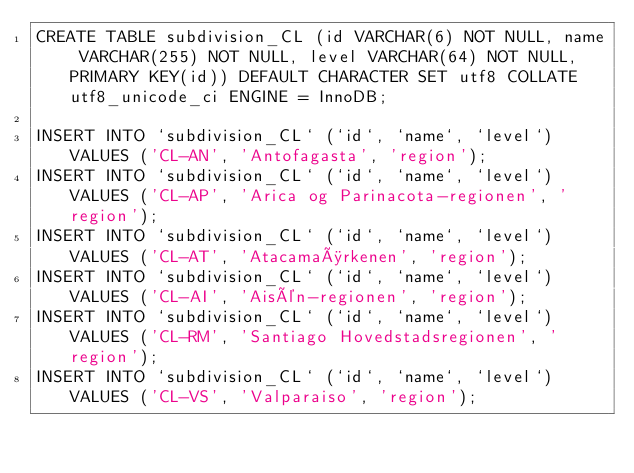<code> <loc_0><loc_0><loc_500><loc_500><_SQL_>CREATE TABLE subdivision_CL (id VARCHAR(6) NOT NULL, name VARCHAR(255) NOT NULL, level VARCHAR(64) NOT NULL, PRIMARY KEY(id)) DEFAULT CHARACTER SET utf8 COLLATE utf8_unicode_ci ENGINE = InnoDB;

INSERT INTO `subdivision_CL` (`id`, `name`, `level`) VALUES ('CL-AN', 'Antofagasta', 'region');
INSERT INTO `subdivision_CL` (`id`, `name`, `level`) VALUES ('CL-AP', 'Arica og Parinacota-regionen', 'region');
INSERT INTO `subdivision_CL` (`id`, `name`, `level`) VALUES ('CL-AT', 'Atacamaørkenen', 'region');
INSERT INTO `subdivision_CL` (`id`, `name`, `level`) VALUES ('CL-AI', 'Aisén-regionen', 'region');
INSERT INTO `subdivision_CL` (`id`, `name`, `level`) VALUES ('CL-RM', 'Santiago Hovedstadsregionen', 'region');
INSERT INTO `subdivision_CL` (`id`, `name`, `level`) VALUES ('CL-VS', 'Valparaiso', 'region');
</code> 